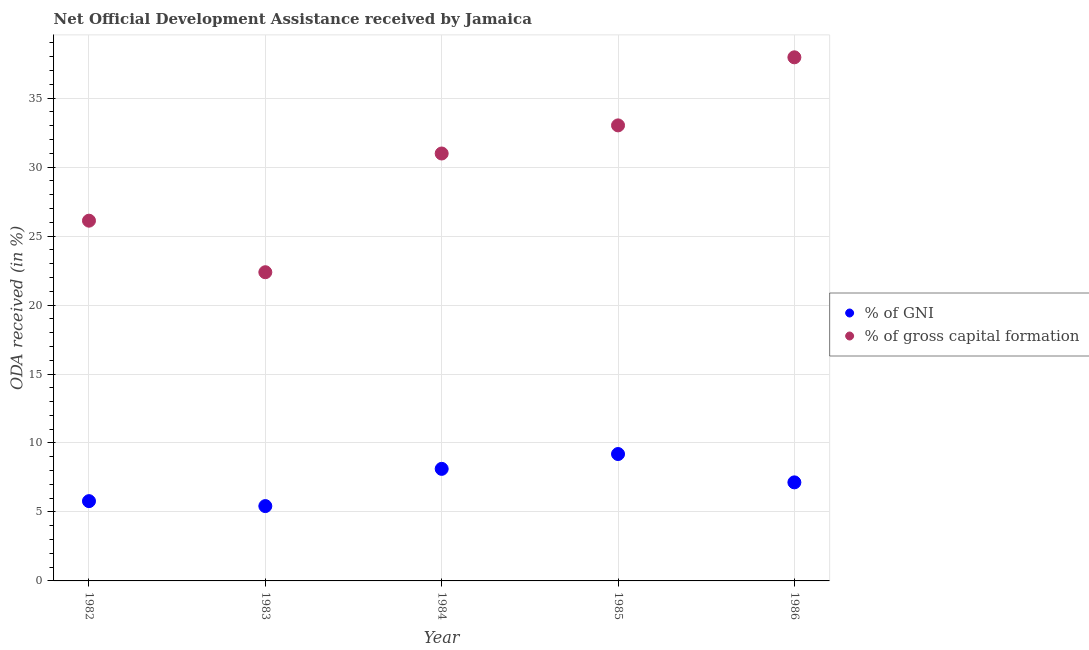How many different coloured dotlines are there?
Offer a very short reply. 2. Is the number of dotlines equal to the number of legend labels?
Ensure brevity in your answer.  Yes. What is the oda received as percentage of gross capital formation in 1986?
Your answer should be very brief. 37.96. Across all years, what is the maximum oda received as percentage of gross capital formation?
Make the answer very short. 37.96. Across all years, what is the minimum oda received as percentage of gni?
Keep it short and to the point. 5.43. In which year was the oda received as percentage of gni maximum?
Keep it short and to the point. 1985. What is the total oda received as percentage of gni in the graph?
Keep it short and to the point. 35.68. What is the difference between the oda received as percentage of gross capital formation in 1984 and that in 1985?
Make the answer very short. -2.04. What is the difference between the oda received as percentage of gross capital formation in 1985 and the oda received as percentage of gni in 1984?
Keep it short and to the point. 24.9. What is the average oda received as percentage of gross capital formation per year?
Keep it short and to the point. 30.09. In the year 1986, what is the difference between the oda received as percentage of gross capital formation and oda received as percentage of gni?
Your answer should be compact. 30.81. In how many years, is the oda received as percentage of gross capital formation greater than 27 %?
Ensure brevity in your answer.  3. What is the ratio of the oda received as percentage of gross capital formation in 1982 to that in 1986?
Provide a succinct answer. 0.69. Is the difference between the oda received as percentage of gni in 1983 and 1986 greater than the difference between the oda received as percentage of gross capital formation in 1983 and 1986?
Your answer should be compact. Yes. What is the difference between the highest and the second highest oda received as percentage of gni?
Give a very brief answer. 1.08. What is the difference between the highest and the lowest oda received as percentage of gni?
Offer a very short reply. 3.77. In how many years, is the oda received as percentage of gni greater than the average oda received as percentage of gni taken over all years?
Your response must be concise. 3. Is the sum of the oda received as percentage of gni in 1983 and 1986 greater than the maximum oda received as percentage of gross capital formation across all years?
Your answer should be very brief. No. Does the oda received as percentage of gross capital formation monotonically increase over the years?
Offer a very short reply. No. How many dotlines are there?
Keep it short and to the point. 2. How many years are there in the graph?
Make the answer very short. 5. Does the graph contain grids?
Make the answer very short. Yes. How many legend labels are there?
Your answer should be very brief. 2. How are the legend labels stacked?
Ensure brevity in your answer.  Vertical. What is the title of the graph?
Give a very brief answer. Net Official Development Assistance received by Jamaica. Does "Ages 15-24" appear as one of the legend labels in the graph?
Your answer should be compact. No. What is the label or title of the Y-axis?
Your response must be concise. ODA received (in %). What is the ODA received (in %) of % of GNI in 1982?
Offer a very short reply. 5.78. What is the ODA received (in %) of % of gross capital formation in 1982?
Your response must be concise. 26.12. What is the ODA received (in %) in % of GNI in 1983?
Offer a terse response. 5.43. What is the ODA received (in %) in % of gross capital formation in 1983?
Your answer should be compact. 22.38. What is the ODA received (in %) of % of GNI in 1984?
Your answer should be compact. 8.12. What is the ODA received (in %) of % of gross capital formation in 1984?
Offer a terse response. 30.99. What is the ODA received (in %) in % of GNI in 1985?
Your answer should be compact. 9.2. What is the ODA received (in %) of % of gross capital formation in 1985?
Make the answer very short. 33.02. What is the ODA received (in %) in % of GNI in 1986?
Provide a succinct answer. 7.14. What is the ODA received (in %) in % of gross capital formation in 1986?
Provide a succinct answer. 37.96. Across all years, what is the maximum ODA received (in %) in % of GNI?
Offer a very short reply. 9.2. Across all years, what is the maximum ODA received (in %) in % of gross capital formation?
Ensure brevity in your answer.  37.96. Across all years, what is the minimum ODA received (in %) in % of GNI?
Provide a succinct answer. 5.43. Across all years, what is the minimum ODA received (in %) of % of gross capital formation?
Make the answer very short. 22.38. What is the total ODA received (in %) in % of GNI in the graph?
Offer a terse response. 35.68. What is the total ODA received (in %) of % of gross capital formation in the graph?
Your answer should be very brief. 150.47. What is the difference between the ODA received (in %) in % of GNI in 1982 and that in 1983?
Your response must be concise. 0.36. What is the difference between the ODA received (in %) in % of gross capital formation in 1982 and that in 1983?
Ensure brevity in your answer.  3.74. What is the difference between the ODA received (in %) in % of GNI in 1982 and that in 1984?
Offer a very short reply. -2.34. What is the difference between the ODA received (in %) in % of gross capital formation in 1982 and that in 1984?
Keep it short and to the point. -4.87. What is the difference between the ODA received (in %) in % of GNI in 1982 and that in 1985?
Make the answer very short. -3.41. What is the difference between the ODA received (in %) in % of gross capital formation in 1982 and that in 1985?
Provide a short and direct response. -6.91. What is the difference between the ODA received (in %) in % of GNI in 1982 and that in 1986?
Ensure brevity in your answer.  -1.36. What is the difference between the ODA received (in %) in % of gross capital formation in 1982 and that in 1986?
Offer a very short reply. -11.84. What is the difference between the ODA received (in %) of % of GNI in 1983 and that in 1984?
Give a very brief answer. -2.7. What is the difference between the ODA received (in %) in % of gross capital formation in 1983 and that in 1984?
Your response must be concise. -8.61. What is the difference between the ODA received (in %) of % of GNI in 1983 and that in 1985?
Your answer should be compact. -3.77. What is the difference between the ODA received (in %) of % of gross capital formation in 1983 and that in 1985?
Make the answer very short. -10.65. What is the difference between the ODA received (in %) in % of GNI in 1983 and that in 1986?
Give a very brief answer. -1.72. What is the difference between the ODA received (in %) of % of gross capital formation in 1983 and that in 1986?
Make the answer very short. -15.58. What is the difference between the ODA received (in %) in % of GNI in 1984 and that in 1985?
Ensure brevity in your answer.  -1.08. What is the difference between the ODA received (in %) in % of gross capital formation in 1984 and that in 1985?
Give a very brief answer. -2.04. What is the difference between the ODA received (in %) in % of GNI in 1984 and that in 1986?
Give a very brief answer. 0.98. What is the difference between the ODA received (in %) of % of gross capital formation in 1984 and that in 1986?
Offer a terse response. -6.97. What is the difference between the ODA received (in %) in % of GNI in 1985 and that in 1986?
Offer a terse response. 2.05. What is the difference between the ODA received (in %) of % of gross capital formation in 1985 and that in 1986?
Your answer should be compact. -4.93. What is the difference between the ODA received (in %) in % of GNI in 1982 and the ODA received (in %) in % of gross capital formation in 1983?
Your response must be concise. -16.6. What is the difference between the ODA received (in %) in % of GNI in 1982 and the ODA received (in %) in % of gross capital formation in 1984?
Keep it short and to the point. -25.2. What is the difference between the ODA received (in %) in % of GNI in 1982 and the ODA received (in %) in % of gross capital formation in 1985?
Make the answer very short. -27.24. What is the difference between the ODA received (in %) of % of GNI in 1982 and the ODA received (in %) of % of gross capital formation in 1986?
Provide a succinct answer. -32.18. What is the difference between the ODA received (in %) of % of GNI in 1983 and the ODA received (in %) of % of gross capital formation in 1984?
Give a very brief answer. -25.56. What is the difference between the ODA received (in %) of % of GNI in 1983 and the ODA received (in %) of % of gross capital formation in 1985?
Offer a terse response. -27.6. What is the difference between the ODA received (in %) of % of GNI in 1983 and the ODA received (in %) of % of gross capital formation in 1986?
Offer a terse response. -32.53. What is the difference between the ODA received (in %) in % of GNI in 1984 and the ODA received (in %) in % of gross capital formation in 1985?
Keep it short and to the point. -24.9. What is the difference between the ODA received (in %) of % of GNI in 1984 and the ODA received (in %) of % of gross capital formation in 1986?
Make the answer very short. -29.84. What is the difference between the ODA received (in %) of % of GNI in 1985 and the ODA received (in %) of % of gross capital formation in 1986?
Give a very brief answer. -28.76. What is the average ODA received (in %) of % of GNI per year?
Provide a short and direct response. 7.14. What is the average ODA received (in %) in % of gross capital formation per year?
Make the answer very short. 30.09. In the year 1982, what is the difference between the ODA received (in %) of % of GNI and ODA received (in %) of % of gross capital formation?
Your answer should be very brief. -20.33. In the year 1983, what is the difference between the ODA received (in %) in % of GNI and ODA received (in %) in % of gross capital formation?
Keep it short and to the point. -16.95. In the year 1984, what is the difference between the ODA received (in %) in % of GNI and ODA received (in %) in % of gross capital formation?
Your response must be concise. -22.86. In the year 1985, what is the difference between the ODA received (in %) in % of GNI and ODA received (in %) in % of gross capital formation?
Give a very brief answer. -23.83. In the year 1986, what is the difference between the ODA received (in %) of % of GNI and ODA received (in %) of % of gross capital formation?
Keep it short and to the point. -30.81. What is the ratio of the ODA received (in %) of % of GNI in 1982 to that in 1983?
Keep it short and to the point. 1.07. What is the ratio of the ODA received (in %) of % of gross capital formation in 1982 to that in 1983?
Give a very brief answer. 1.17. What is the ratio of the ODA received (in %) in % of GNI in 1982 to that in 1984?
Offer a terse response. 0.71. What is the ratio of the ODA received (in %) of % of gross capital formation in 1982 to that in 1984?
Offer a very short reply. 0.84. What is the ratio of the ODA received (in %) in % of GNI in 1982 to that in 1985?
Your answer should be very brief. 0.63. What is the ratio of the ODA received (in %) in % of gross capital formation in 1982 to that in 1985?
Offer a terse response. 0.79. What is the ratio of the ODA received (in %) in % of GNI in 1982 to that in 1986?
Provide a short and direct response. 0.81. What is the ratio of the ODA received (in %) in % of gross capital formation in 1982 to that in 1986?
Ensure brevity in your answer.  0.69. What is the ratio of the ODA received (in %) of % of GNI in 1983 to that in 1984?
Give a very brief answer. 0.67. What is the ratio of the ODA received (in %) in % of gross capital formation in 1983 to that in 1984?
Your answer should be very brief. 0.72. What is the ratio of the ODA received (in %) in % of GNI in 1983 to that in 1985?
Offer a very short reply. 0.59. What is the ratio of the ODA received (in %) in % of gross capital formation in 1983 to that in 1985?
Keep it short and to the point. 0.68. What is the ratio of the ODA received (in %) of % of GNI in 1983 to that in 1986?
Your answer should be compact. 0.76. What is the ratio of the ODA received (in %) of % of gross capital formation in 1983 to that in 1986?
Give a very brief answer. 0.59. What is the ratio of the ODA received (in %) of % of GNI in 1984 to that in 1985?
Keep it short and to the point. 0.88. What is the ratio of the ODA received (in %) of % of gross capital formation in 1984 to that in 1985?
Give a very brief answer. 0.94. What is the ratio of the ODA received (in %) in % of GNI in 1984 to that in 1986?
Ensure brevity in your answer.  1.14. What is the ratio of the ODA received (in %) of % of gross capital formation in 1984 to that in 1986?
Ensure brevity in your answer.  0.82. What is the ratio of the ODA received (in %) in % of GNI in 1985 to that in 1986?
Provide a short and direct response. 1.29. What is the ratio of the ODA received (in %) of % of gross capital formation in 1985 to that in 1986?
Give a very brief answer. 0.87. What is the difference between the highest and the second highest ODA received (in %) of % of GNI?
Make the answer very short. 1.08. What is the difference between the highest and the second highest ODA received (in %) of % of gross capital formation?
Ensure brevity in your answer.  4.93. What is the difference between the highest and the lowest ODA received (in %) of % of GNI?
Your response must be concise. 3.77. What is the difference between the highest and the lowest ODA received (in %) of % of gross capital formation?
Provide a succinct answer. 15.58. 